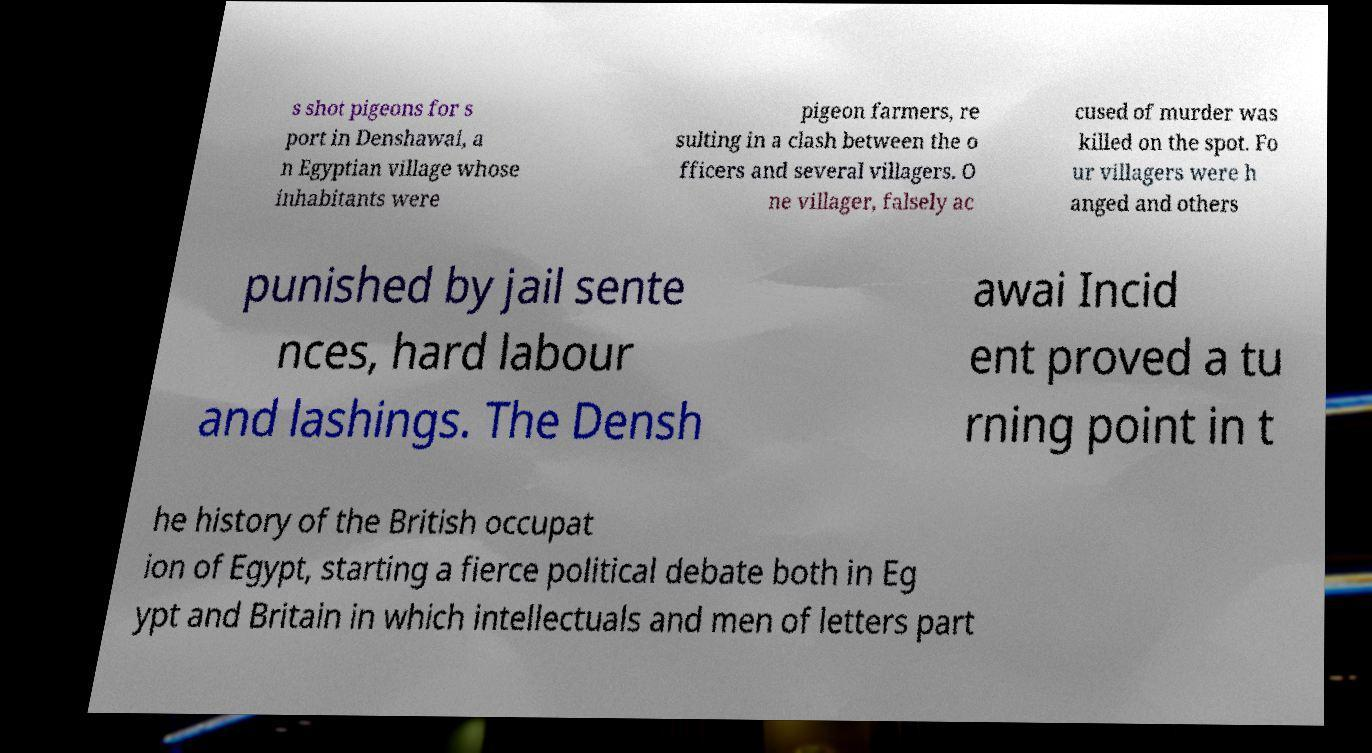What messages or text are displayed in this image? I need them in a readable, typed format. s shot pigeons for s port in Denshawai, a n Egyptian village whose inhabitants were pigeon farmers, re sulting in a clash between the o fficers and several villagers. O ne villager, falsely ac cused of murder was killed on the spot. Fo ur villagers were h anged and others punished by jail sente nces, hard labour and lashings. The Densh awai Incid ent proved a tu rning point in t he history of the British occupat ion of Egypt, starting a fierce political debate both in Eg ypt and Britain in which intellectuals and men of letters part 